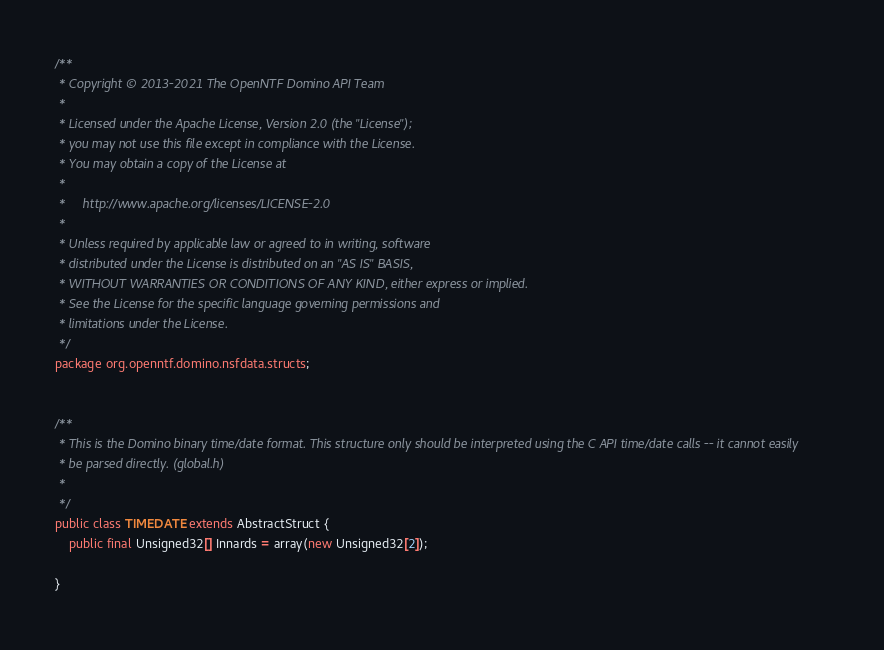<code> <loc_0><loc_0><loc_500><loc_500><_Java_>/**
 * Copyright © 2013-2021 The OpenNTF Domino API Team
 *
 * Licensed under the Apache License, Version 2.0 (the "License");
 * you may not use this file except in compliance with the License.
 * You may obtain a copy of the License at
 *
 *     http://www.apache.org/licenses/LICENSE-2.0
 *
 * Unless required by applicable law or agreed to in writing, software
 * distributed under the License is distributed on an "AS IS" BASIS,
 * WITHOUT WARRANTIES OR CONDITIONS OF ANY KIND, either express or implied.
 * See the License for the specific language governing permissions and
 * limitations under the License.
 */
package org.openntf.domino.nsfdata.structs;


/**
 * This is the Domino binary time/date format. This structure only should be interpreted using the C API time/date calls -- it cannot easily
 * be parsed directly. (global.h)
 *
 */
public class TIMEDATE extends AbstractStruct {
	public final Unsigned32[] Innards = array(new Unsigned32[2]);

}
</code> 